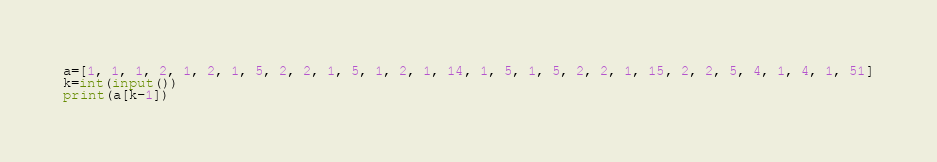Convert code to text. <code><loc_0><loc_0><loc_500><loc_500><_Python_>a=[1, 1, 1, 2, 1, 2, 1, 5, 2, 2, 1, 5, 1, 2, 1, 14, 1, 5, 1, 5, 2, 2, 1, 15, 2, 2, 5, 4, 1, 4, 1, 51]
k=int(input())
print(a[k-1])</code> 